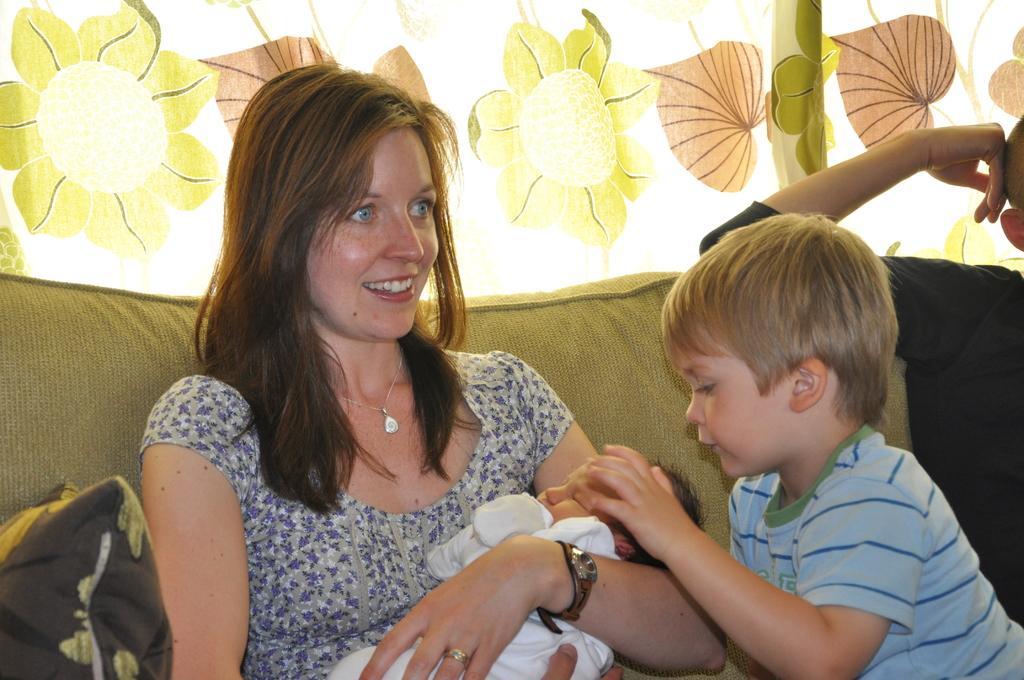Can you describe this image briefly? In this image we can see a lady wearing neck chain, watch and ring. She is holding a baby. Near to her there is a child and a man. They are sitting on a sofa. Also there is a pillow. In the back there is curtain. 